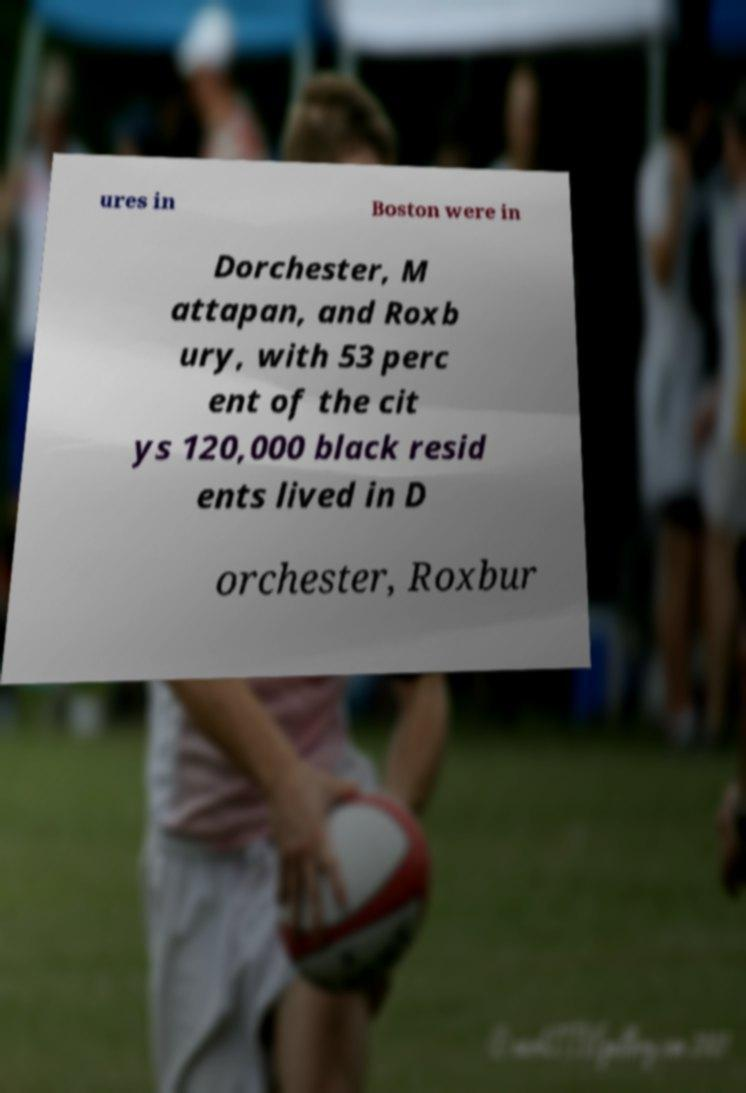What messages or text are displayed in this image? I need them in a readable, typed format. ures in Boston were in Dorchester, M attapan, and Roxb ury, with 53 perc ent of the cit ys 120,000 black resid ents lived in D orchester, Roxbur 